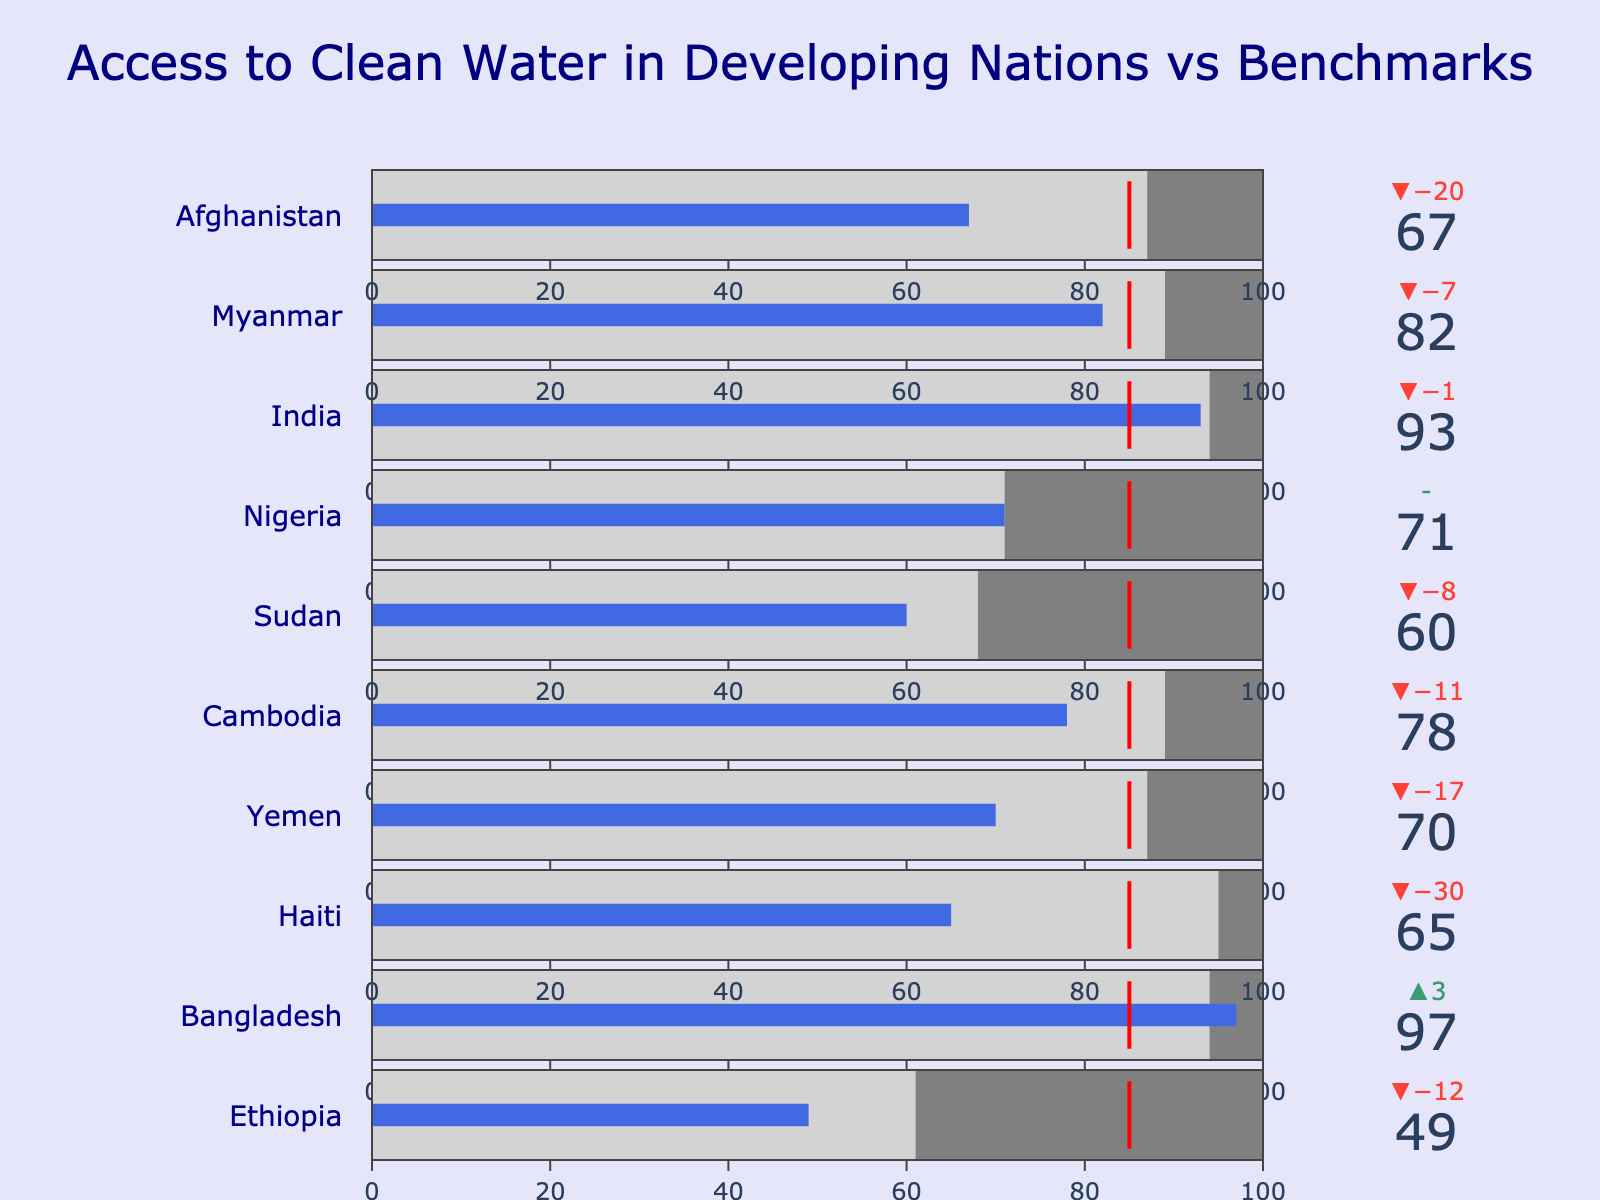What's the title of the chart? The title is usually located at the top of the chart. Here, the title reads "Access to Clean Water in Developing Nations vs Benchmarks."
Answer: Access to Clean Water in Developing Nations vs Benchmarks Which country has the highest access to clean water? By examining the bullet chart, Bangladesh has the highest access to clean water with a value of 97%.
Answer: Bangladesh Which country is furthest behind its regional average in access to clean water? Look for the country with the largest negative delta between Access to Clean Water (%) and Regional Average (%). Haiti has an access rate of 65%, while its regional average is 95%, so it has a deficit of 30%.
Answer: Haiti What does the red marker represent in the chart? The red marker, a common feature in bullet charts, indicates the global benchmark for access to clean water, which is 85%.
Answer: The global benchmark (85%) Which country just meets the regional average for access to clean water? By observing the values and deltas, Nigeria has an Access to Clean Water (%) of 71%, exactly matching its Regional Average (%).
Answer: Nigeria How does Ethiopia's access to clean water compare to the global benchmark? Ethiopia has an access rate of 49%, while the global benchmark is 85%. This indicates Ethiopia is 36% below the global benchmark.
Answer: 36% below Which countries exceed both their regional average and the global benchmark? Review each country’s access rate compared to both their regional averages and the global benchmark. Bangladesh and India both meet and exceed these standards, with 97% and 93% access rates respectively, and both surpass 85%.
Answer: Bangladesh, India What's the average access to clean water percentage across all countries? Add up the access percentages for all 10 countries and divide by 10: (49 + 97 + 65 + 70 + 78 + 60 + 71 + 93 + 82 + 67) / 10 = 73.2%.
Answer: 73.2% Which country has the smallest difference between its access rate and the global benchmark? Compare the differences between each country’s access percentage and 85%. Nigeria has an access rate of 71%, which is the closest to the benchmark with a difference of 14%.
Answer: Nigeria 